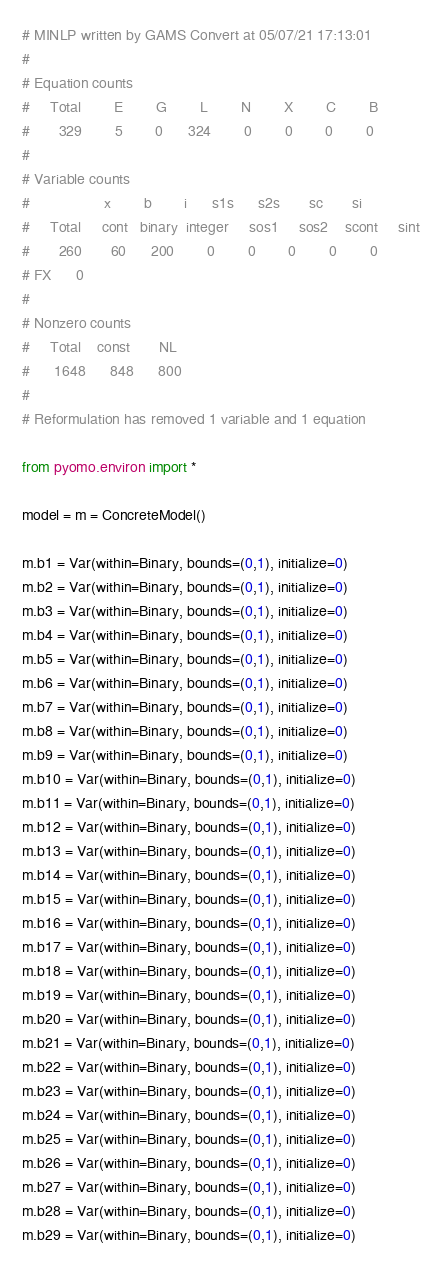<code> <loc_0><loc_0><loc_500><loc_500><_Python_># MINLP written by GAMS Convert at 05/07/21 17:13:01
#
# Equation counts
#     Total        E        G        L        N        X        C        B
#       329        5        0      324        0        0        0        0
#
# Variable counts
#                  x        b        i      s1s      s2s       sc       si
#     Total     cont   binary  integer     sos1     sos2    scont     sint
#       260       60      200        0        0        0        0        0
# FX      0
#
# Nonzero counts
#     Total    const       NL
#      1648      848      800
#
# Reformulation has removed 1 variable and 1 equation

from pyomo.environ import *

model = m = ConcreteModel()

m.b1 = Var(within=Binary, bounds=(0,1), initialize=0)
m.b2 = Var(within=Binary, bounds=(0,1), initialize=0)
m.b3 = Var(within=Binary, bounds=(0,1), initialize=0)
m.b4 = Var(within=Binary, bounds=(0,1), initialize=0)
m.b5 = Var(within=Binary, bounds=(0,1), initialize=0)
m.b6 = Var(within=Binary, bounds=(0,1), initialize=0)
m.b7 = Var(within=Binary, bounds=(0,1), initialize=0)
m.b8 = Var(within=Binary, bounds=(0,1), initialize=0)
m.b9 = Var(within=Binary, bounds=(0,1), initialize=0)
m.b10 = Var(within=Binary, bounds=(0,1), initialize=0)
m.b11 = Var(within=Binary, bounds=(0,1), initialize=0)
m.b12 = Var(within=Binary, bounds=(0,1), initialize=0)
m.b13 = Var(within=Binary, bounds=(0,1), initialize=0)
m.b14 = Var(within=Binary, bounds=(0,1), initialize=0)
m.b15 = Var(within=Binary, bounds=(0,1), initialize=0)
m.b16 = Var(within=Binary, bounds=(0,1), initialize=0)
m.b17 = Var(within=Binary, bounds=(0,1), initialize=0)
m.b18 = Var(within=Binary, bounds=(0,1), initialize=0)
m.b19 = Var(within=Binary, bounds=(0,1), initialize=0)
m.b20 = Var(within=Binary, bounds=(0,1), initialize=0)
m.b21 = Var(within=Binary, bounds=(0,1), initialize=0)
m.b22 = Var(within=Binary, bounds=(0,1), initialize=0)
m.b23 = Var(within=Binary, bounds=(0,1), initialize=0)
m.b24 = Var(within=Binary, bounds=(0,1), initialize=0)
m.b25 = Var(within=Binary, bounds=(0,1), initialize=0)
m.b26 = Var(within=Binary, bounds=(0,1), initialize=0)
m.b27 = Var(within=Binary, bounds=(0,1), initialize=0)
m.b28 = Var(within=Binary, bounds=(0,1), initialize=0)
m.b29 = Var(within=Binary, bounds=(0,1), initialize=0)</code> 